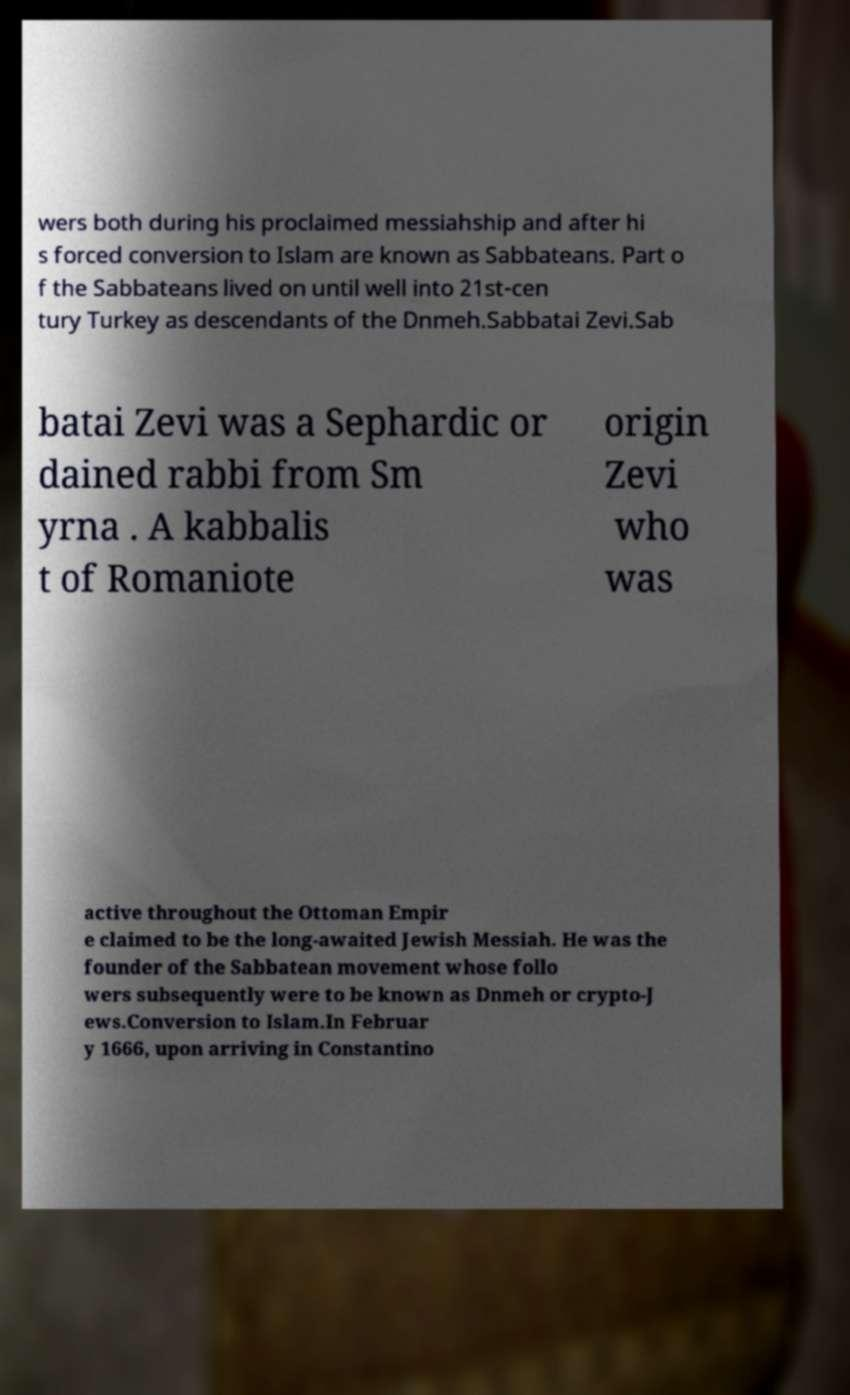Could you extract and type out the text from this image? wers both during his proclaimed messiahship and after hi s forced conversion to Islam are known as Sabbateans. Part o f the Sabbateans lived on until well into 21st-cen tury Turkey as descendants of the Dnmeh.Sabbatai Zevi.Sab batai Zevi was a Sephardic or dained rabbi from Sm yrna . A kabbalis t of Romaniote origin Zevi who was active throughout the Ottoman Empir e claimed to be the long-awaited Jewish Messiah. He was the founder of the Sabbatean movement whose follo wers subsequently were to be known as Dnmeh or crypto-J ews.Conversion to Islam.In Februar y 1666, upon arriving in Constantino 